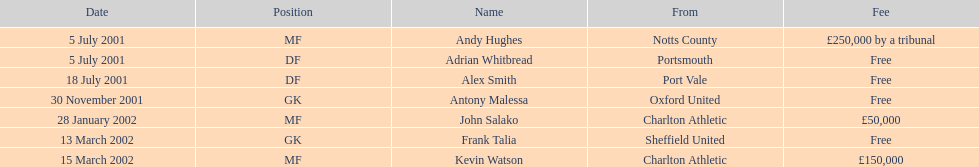Did andy hughes or john salako command the largest fee? Andy Hughes. 